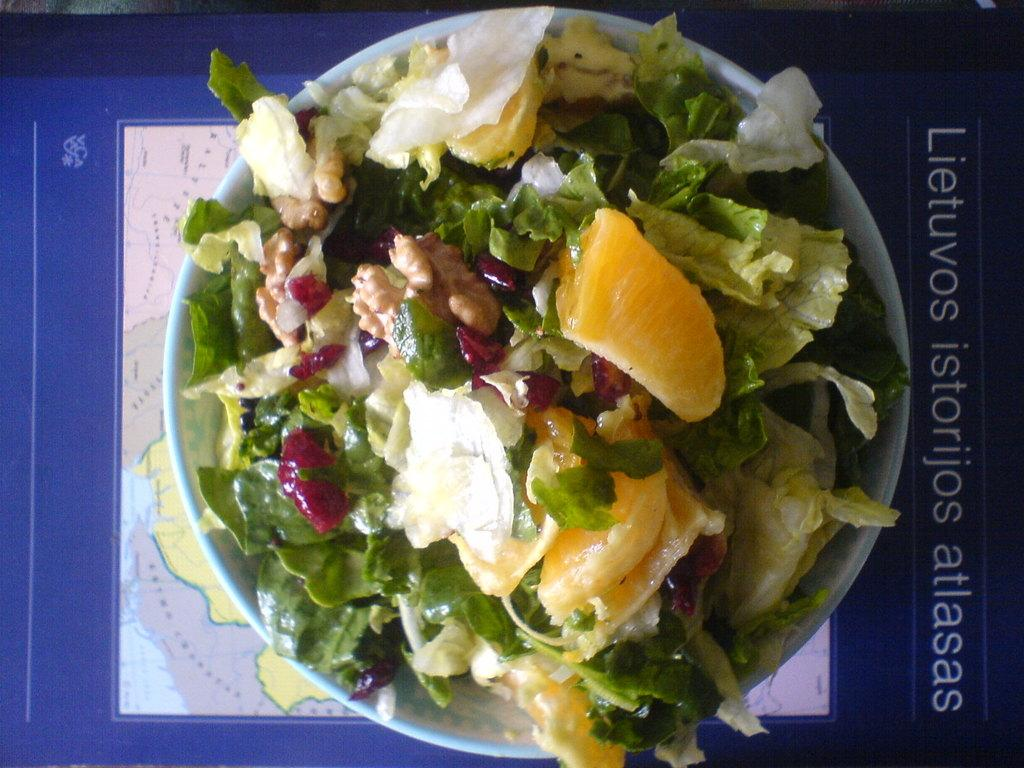What is in the bowl that is visible in the image? There is a food item in a bowl in the image. What is the color of the surface beneath the bowl? The surface beneath the bowl is blue in color. Is there an umbrella being used to serve the food item in the image? No, there is no umbrella present in the image. What type of loaf is being served with the food item in the image? There is no loaf present in the image; it only shows a food item in a bowl. 